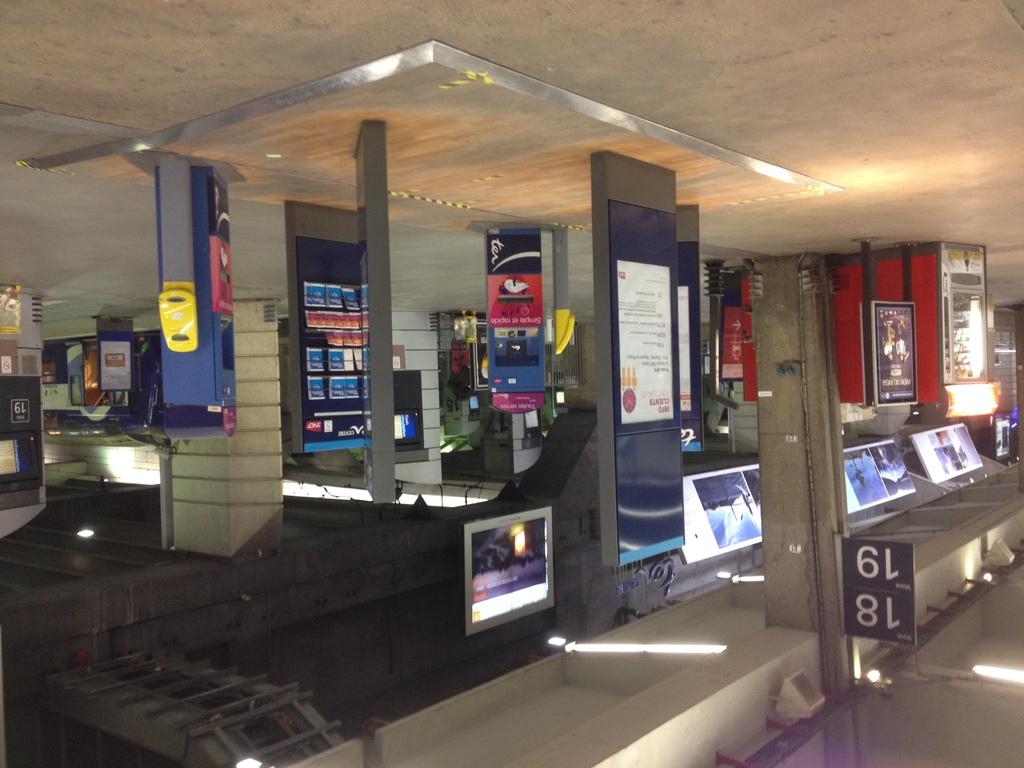What is the smallest number on the bottom of the pole?
Your answer should be compact. 18. What is the largest number on the top of the pole?
Give a very brief answer. 19. 